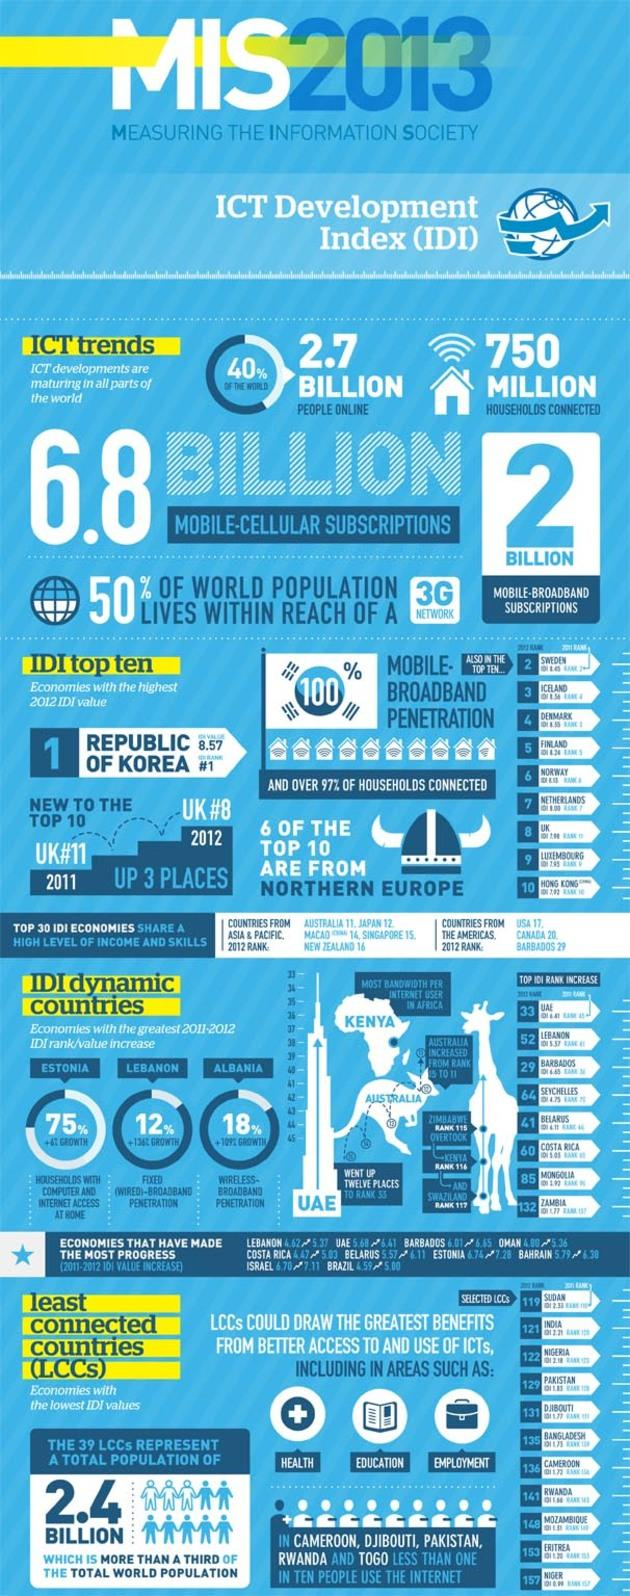Outline some significant characteristics in this image. In 2013, the number of mobile-broadband subscriptions worldwide was approximately 2 billion. Kenya has the highest bandwidth per internet user in Africa. In 2012, the United Kingdom had an International Development Index (IDI) rank of 8 out of 146 countries surveyed. Iceland has the third highest IDI rank in 2012. The Republic of Korea had 100% mobile broadband penetration in 2012, making it the country with the highest level of mobile broadband usage. 